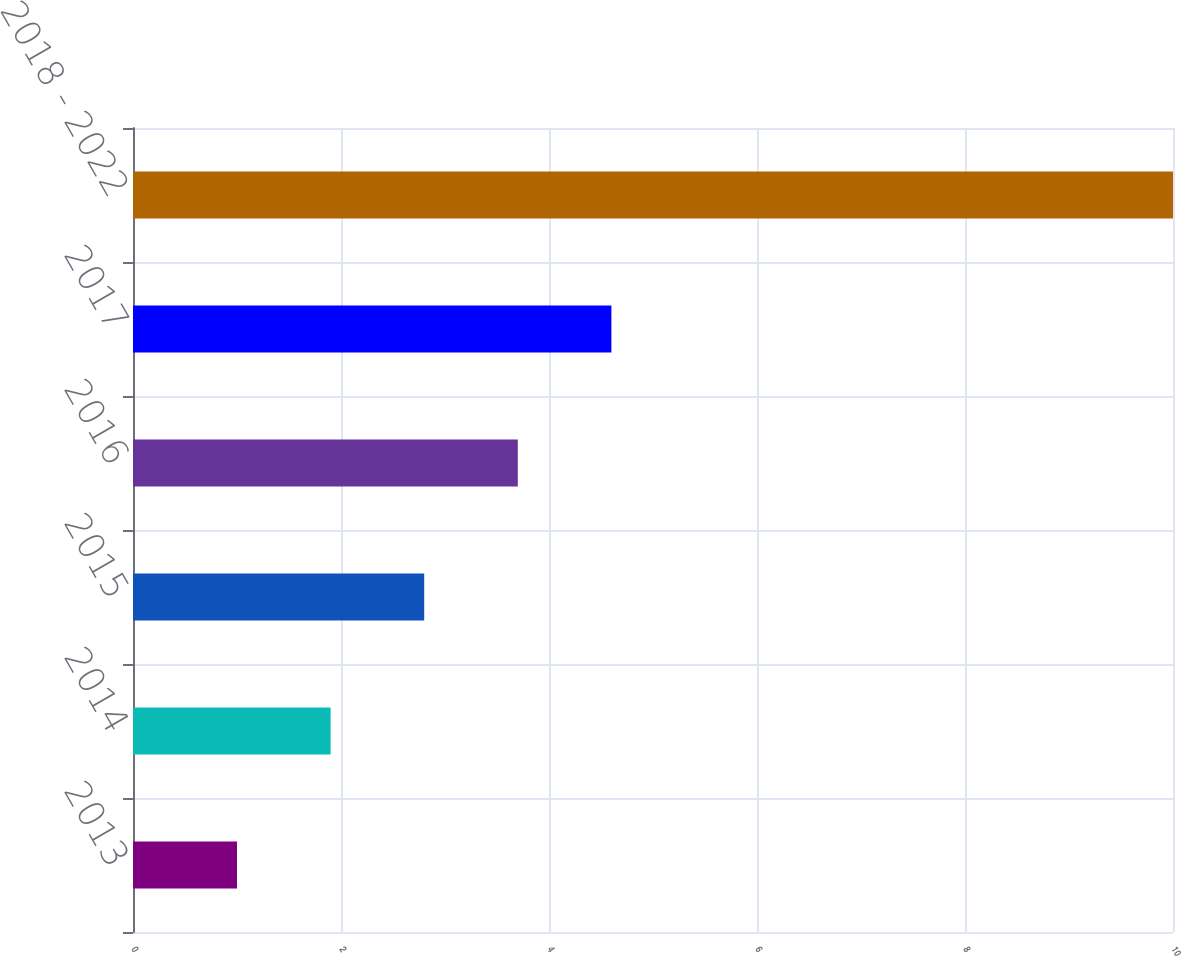Convert chart to OTSL. <chart><loc_0><loc_0><loc_500><loc_500><bar_chart><fcel>2013<fcel>2014<fcel>2015<fcel>2016<fcel>2017<fcel>2018 - 2022<nl><fcel>1<fcel>1.9<fcel>2.8<fcel>3.7<fcel>4.6<fcel>10<nl></chart> 